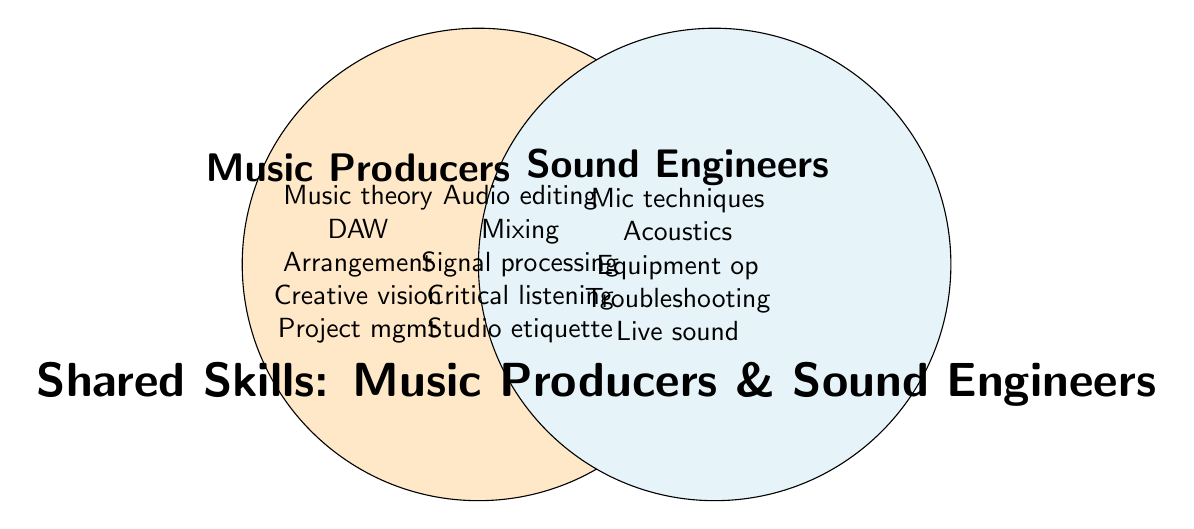What is the title of the Venn Diagram? The title can be found at the bottom of the diagram. It indicates the main topic of the Venn Diagram.
Answer: Shared Skills: Music Producers & Sound Engineers What color represents the skills specific to Music Producers? The color that fills the circle on the left-hand side represents skills specific to Music Producers.
Answer: Orange How many unique skills do Sound Engineers have that Music Producers do not? Look at the list of skills within the Sound Engineers' circle that are not in the overlapping area. Count these unique skills.
Answer: 5 What are the shared skills between Music Producers and Sound Engineers listed in the Venn Diagram? Focus on the center overlapping area of the diagram; it lists the skills shared by both Music Producers and Sound Engineers.
Answer: Audio editing, Mixing, Signal processing, Critical listening, Studio etiquette Which unique skill category has more skills: Music Producers or Sound Engineers? Count the unique skills listed for each category (Music Producers on the left, Sound Engineers on the right) and compare the counts.
Answer: Sound Engineers Which skill is associated with Signal Processing? Identify the region where Signal Processing is located. The skill is in the shared section, indicating it is associated with both.
Answer: Both How many skills total are represented in the Venn Diagram for Music Producers, Sound Engineers, and shared skills? Add the number of unique skills for Music Producers, unique skills for Sound Engineers, and shared skills.
Answer: 15 What area does "Critical listening" belong to in the Venn Diagram? Locate the skill in the Venn Diagram; it is in the overlapping section, indicating it belongs to the shared skills between both groups.
Answer: Shared Skills Name a skill listed under Music Producers that is not shared with Sound Engineers. Identify and select any skill listed only in the Music Producers' circle, not in the overlapping section.
Answer: Music theory 